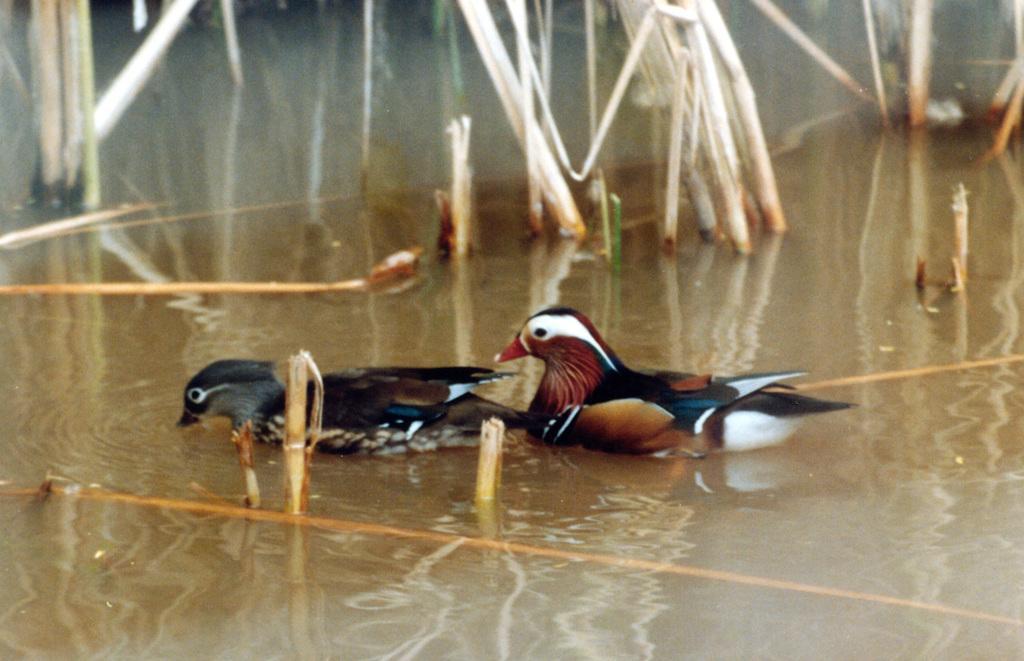Can you describe this image briefly? In this image on the water body there are two birds and plants are there. 